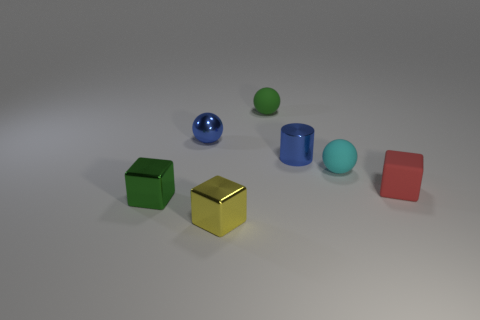Is there a cyan metal thing?
Your response must be concise. No. What is the size of the blue metallic object that is on the right side of the object in front of the small green shiny cube?
Your answer should be very brief. Small. Is the number of metal balls in front of the tiny green cube greater than the number of shiny cylinders in front of the yellow object?
Your response must be concise. No. What number of cubes are either small gray metal objects or green rubber objects?
Offer a very short reply. 0. Is there anything else that is the same size as the green metal cube?
Your answer should be very brief. Yes. There is a green object to the left of the blue metal sphere; is its shape the same as the small red thing?
Your answer should be compact. Yes. What color is the tiny metal sphere?
Provide a succinct answer. Blue. There is another tiny matte object that is the same shape as the green matte object; what is its color?
Your answer should be compact. Cyan. How many green objects are the same shape as the yellow thing?
Provide a succinct answer. 1. How many things are either cyan shiny blocks or things that are on the left side of the green sphere?
Provide a short and direct response. 3. 